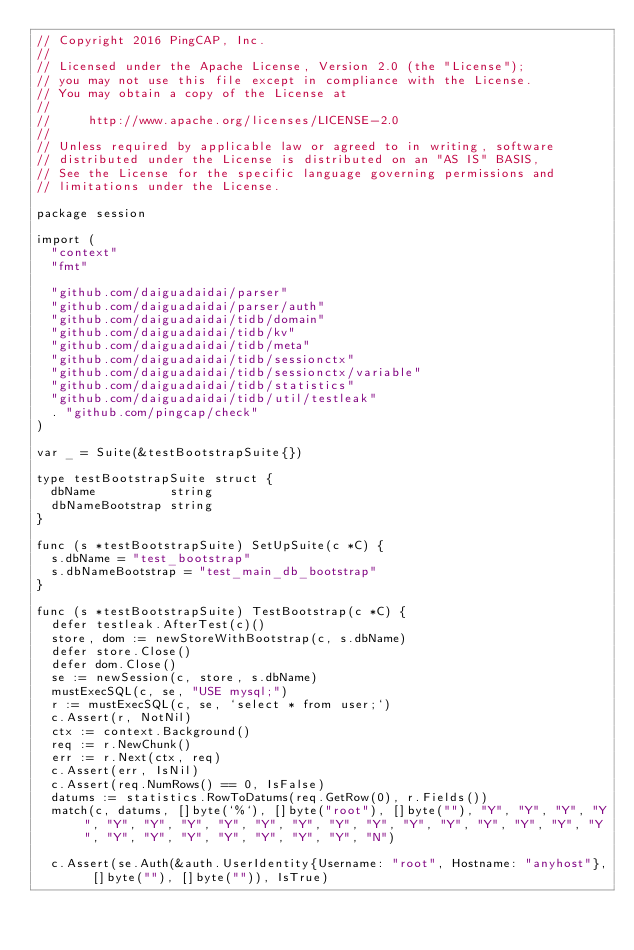<code> <loc_0><loc_0><loc_500><loc_500><_Go_>// Copyright 2016 PingCAP, Inc.
//
// Licensed under the Apache License, Version 2.0 (the "License");
// you may not use this file except in compliance with the License.
// You may obtain a copy of the License at
//
//     http://www.apache.org/licenses/LICENSE-2.0
//
// Unless required by applicable law or agreed to in writing, software
// distributed under the License is distributed on an "AS IS" BASIS,
// See the License for the specific language governing permissions and
// limitations under the License.

package session

import (
	"context"
	"fmt"

	"github.com/daiguadaidai/parser"
	"github.com/daiguadaidai/parser/auth"
	"github.com/daiguadaidai/tidb/domain"
	"github.com/daiguadaidai/tidb/kv"
	"github.com/daiguadaidai/tidb/meta"
	"github.com/daiguadaidai/tidb/sessionctx"
	"github.com/daiguadaidai/tidb/sessionctx/variable"
	"github.com/daiguadaidai/tidb/statistics"
	"github.com/daiguadaidai/tidb/util/testleak"
	. "github.com/pingcap/check"
)

var _ = Suite(&testBootstrapSuite{})

type testBootstrapSuite struct {
	dbName          string
	dbNameBootstrap string
}

func (s *testBootstrapSuite) SetUpSuite(c *C) {
	s.dbName = "test_bootstrap"
	s.dbNameBootstrap = "test_main_db_bootstrap"
}

func (s *testBootstrapSuite) TestBootstrap(c *C) {
	defer testleak.AfterTest(c)()
	store, dom := newStoreWithBootstrap(c, s.dbName)
	defer store.Close()
	defer dom.Close()
	se := newSession(c, store, s.dbName)
	mustExecSQL(c, se, "USE mysql;")
	r := mustExecSQL(c, se, `select * from user;`)
	c.Assert(r, NotNil)
	ctx := context.Background()
	req := r.NewChunk()
	err := r.Next(ctx, req)
	c.Assert(err, IsNil)
	c.Assert(req.NumRows() == 0, IsFalse)
	datums := statistics.RowToDatums(req.GetRow(0), r.Fields())
	match(c, datums, []byte(`%`), []byte("root"), []byte(""), "Y", "Y", "Y", "Y", "Y", "Y", "Y", "Y", "Y", "Y", "Y", "Y", "Y", "Y", "Y", "Y", "Y", "Y", "Y", "Y", "Y", "Y", "Y", "Y", "Y", "N")

	c.Assert(se.Auth(&auth.UserIdentity{Username: "root", Hostname: "anyhost"}, []byte(""), []byte("")), IsTrue)</code> 